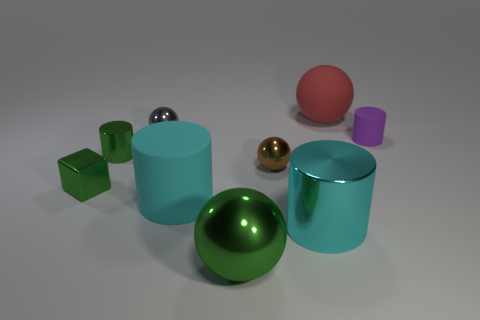Subtract all tiny purple cylinders. How many cylinders are left? 3 Subtract all green cylinders. How many cylinders are left? 3 Subtract all green cylinders. How many red cubes are left? 0 Add 1 tiny purple matte cylinders. How many objects exist? 10 Subtract 3 spheres. How many spheres are left? 1 Subtract all purple cylinders. Subtract all blue blocks. How many cylinders are left? 3 Subtract all large green metal objects. Subtract all big cyan matte cylinders. How many objects are left? 7 Add 1 small gray metal things. How many small gray metal things are left? 2 Add 5 small balls. How many small balls exist? 7 Subtract 0 brown cylinders. How many objects are left? 9 